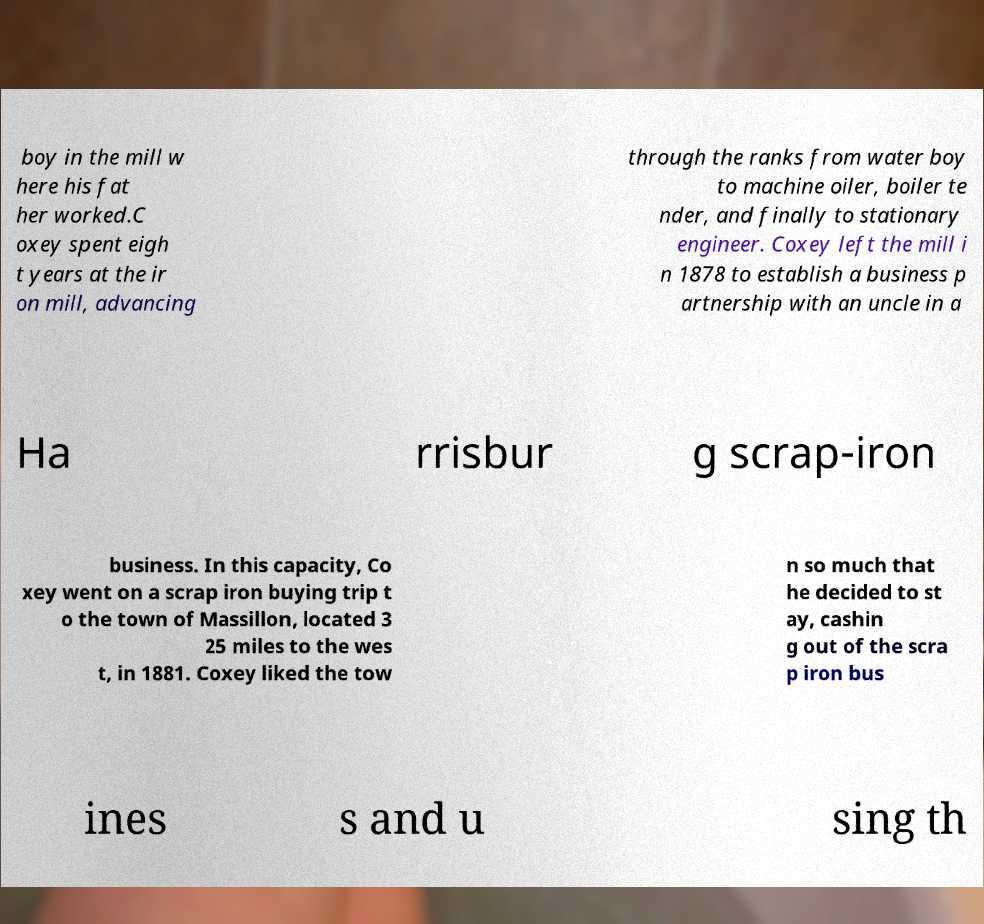There's text embedded in this image that I need extracted. Can you transcribe it verbatim? boy in the mill w here his fat her worked.C oxey spent eigh t years at the ir on mill, advancing through the ranks from water boy to machine oiler, boiler te nder, and finally to stationary engineer. Coxey left the mill i n 1878 to establish a business p artnership with an uncle in a Ha rrisbur g scrap-iron business. In this capacity, Co xey went on a scrap iron buying trip t o the town of Massillon, located 3 25 miles to the wes t, in 1881. Coxey liked the tow n so much that he decided to st ay, cashin g out of the scra p iron bus ines s and u sing th 